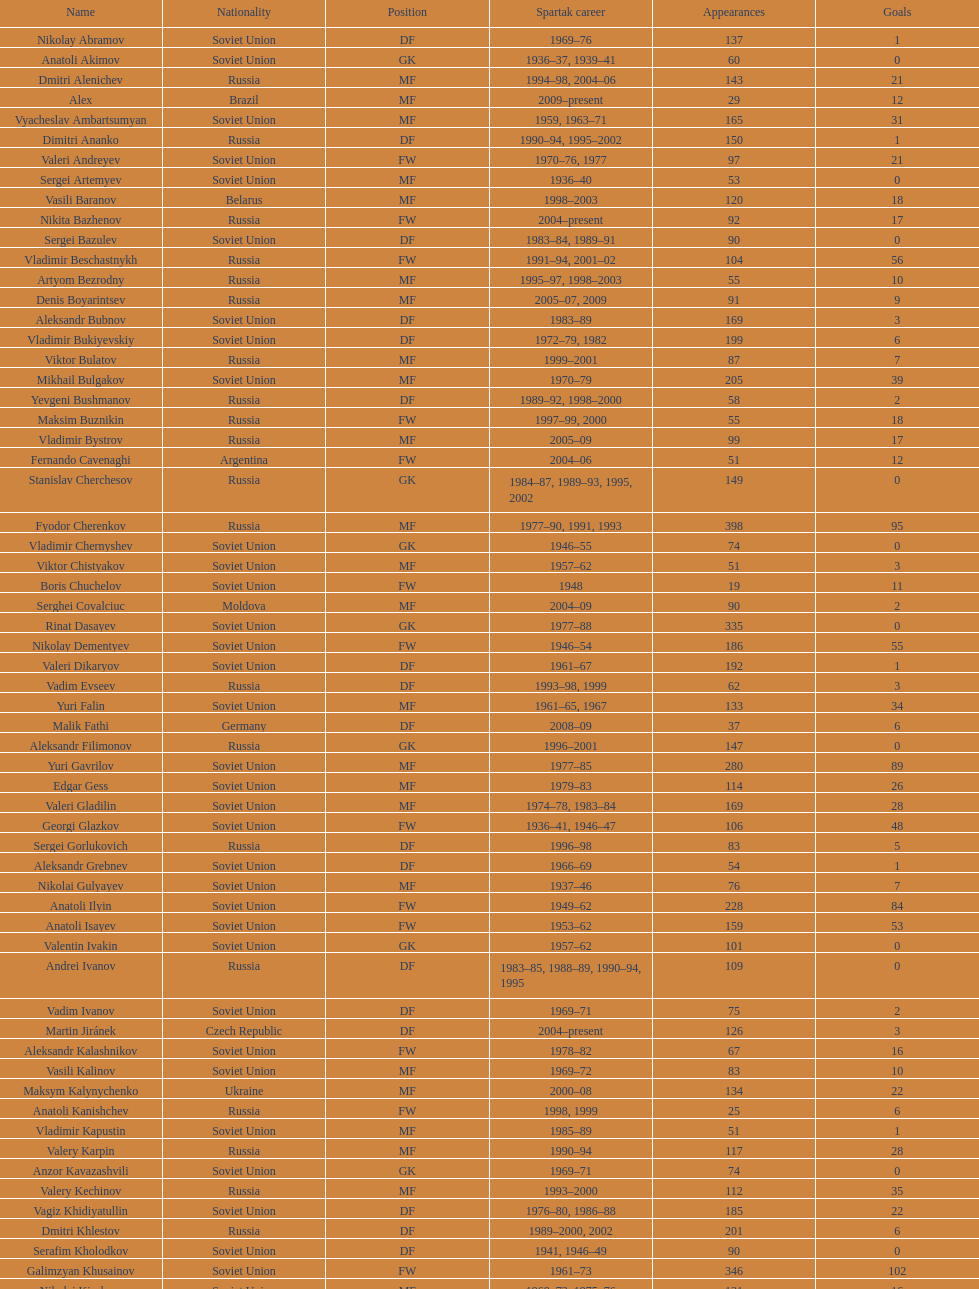What is the number of players who achieved 20 or more league goals? 56. 